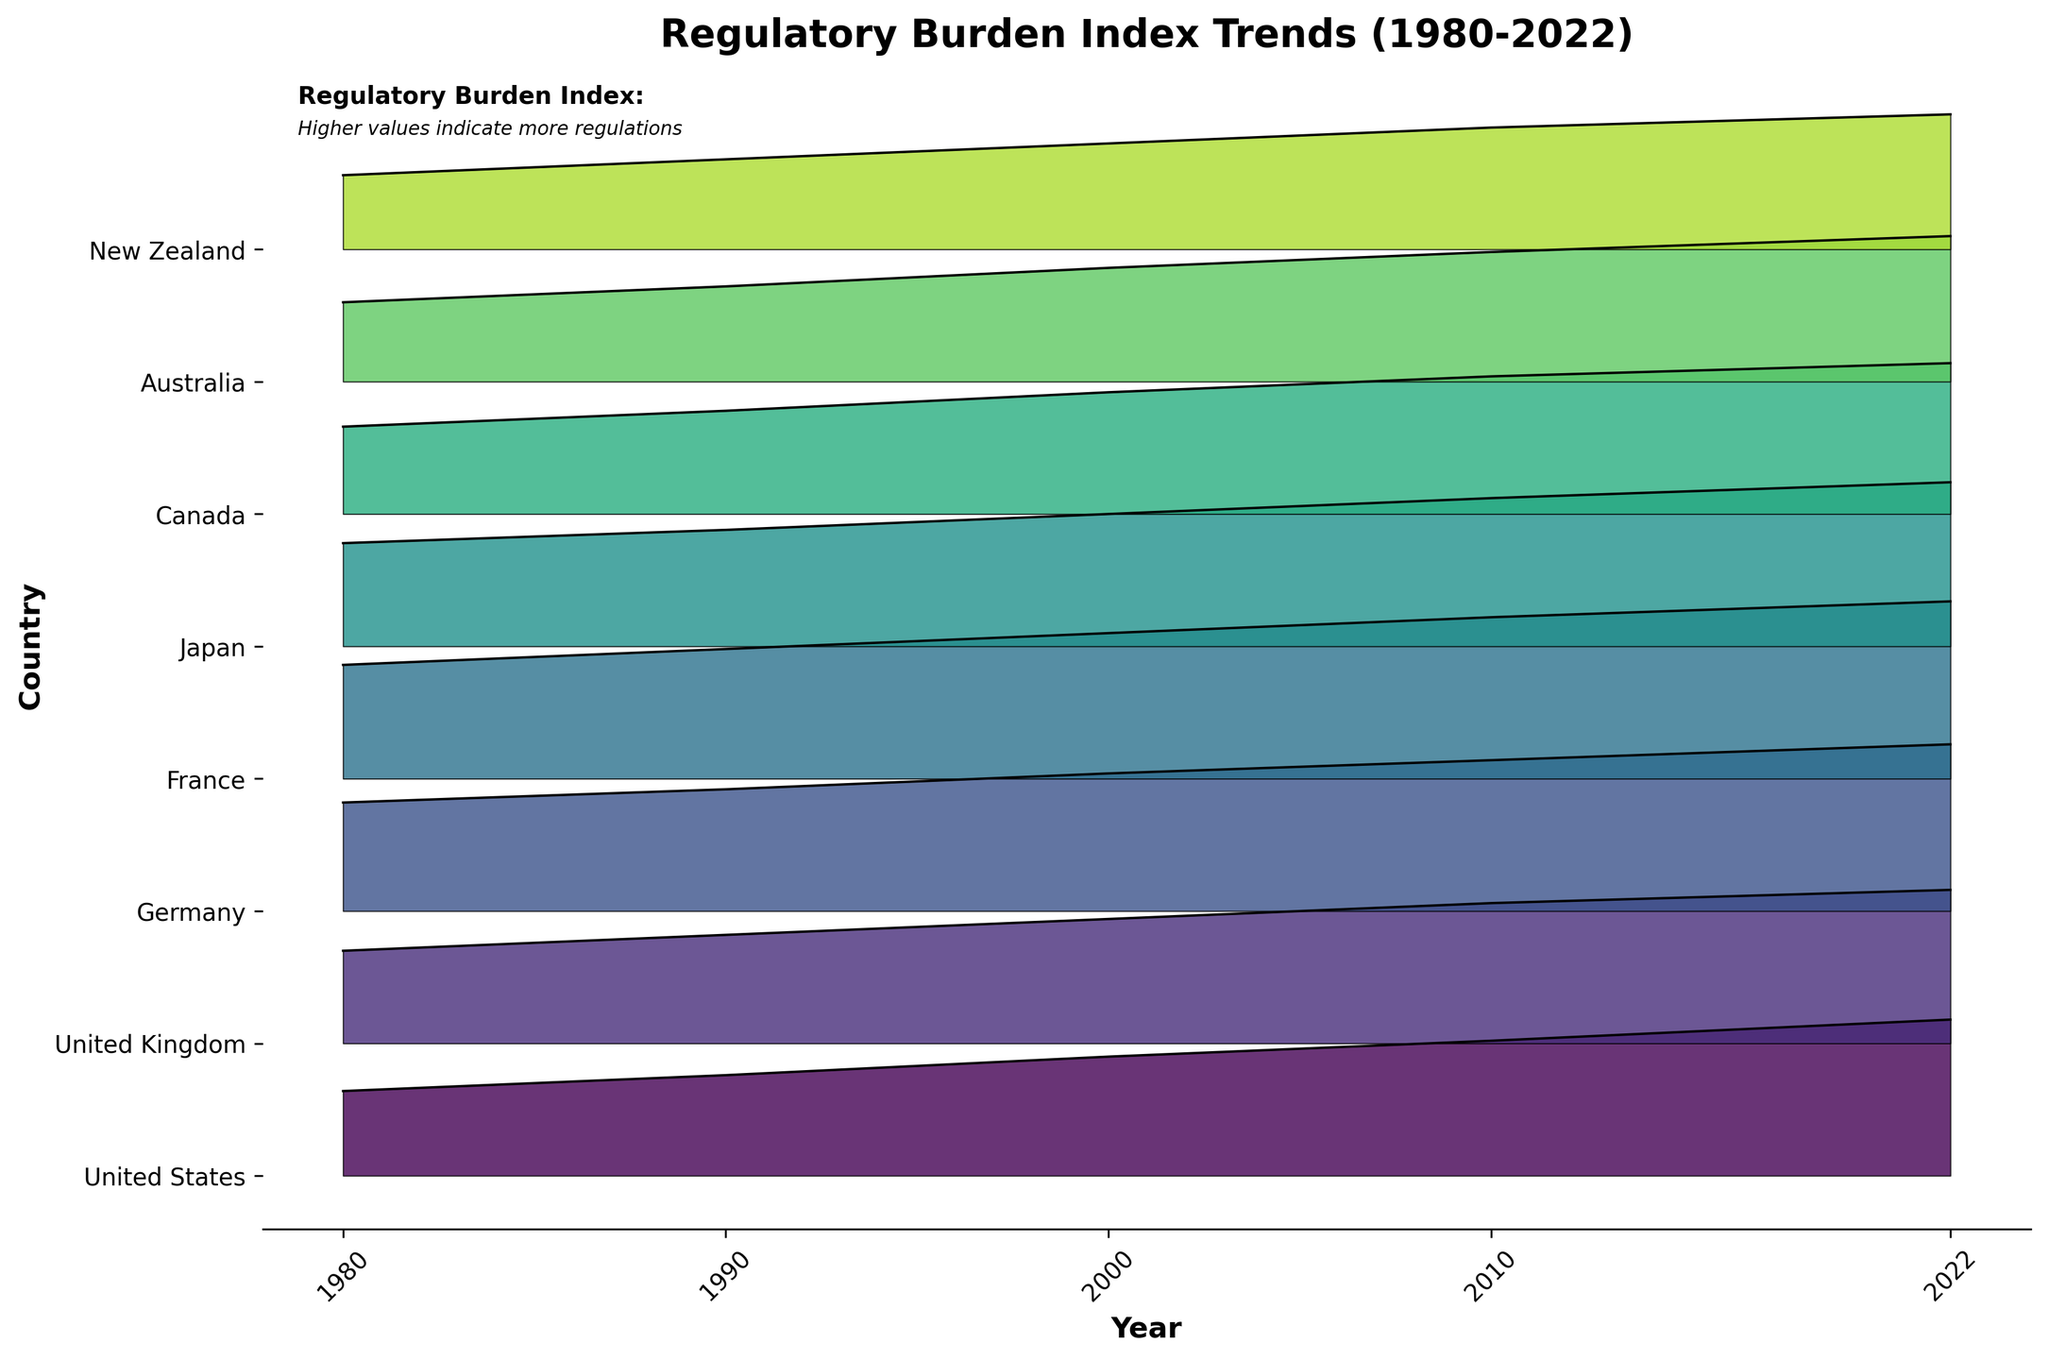what is the title of the figure? The title of the figure is displayed at the top of the plot.
Answer: Regulatory Burden Index Trends (1980-2022) Which country has the highest regulatory burden index in 2022? Look at the right end of the plot and find the country with the highest filled area.
Answer: France How has the regulatory burden index for Germany changed from 1980 to 2022? For Germany, follow the filled area line from left (1980) to right (2022) to see the trend.
Answer: Increased Which country shows the lowest regulatory burden index in 1980? Look at the leftmost end of the plot and find the country with the lowest filled area at the starting point.
Answer: New Zealand List the countries that have a regulatory burden index greater than 5.0 in 2000. Find the 2000 tick on the x-axis and look above it to see which countries have heights above 5.0.
Answer: Germany, France, Japan Between which two consecutive decades did the United Kingdom see the largest increase in its regulatory burden index? For the United Kingdom, compare the height differences for consecutive decades and find the largest one.
Answer: 1980 to 1990 Identify the country with the steepest increase in regulatory burden index from 2010 to 2022. Compare the slopes of the filled areas between 2010 and 2022 for each country and identify the steepest one.
Answer: Germany Which countries experienced an increase in their regulatory burden index every decade from 1980 to 2022? Look for countries with continuously increasing filled areas at each decade marker.
Answer: All listed countries Compare the regulatory burden indexes of the United States and Canada in 1990 and identify which country had a higher index. Look at the heights of the areas for the United States and Canada in the 1990 column.
Answer: United States 